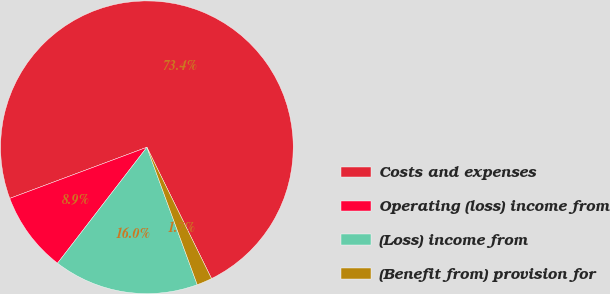Convert chart to OTSL. <chart><loc_0><loc_0><loc_500><loc_500><pie_chart><fcel>Costs and expenses<fcel>Operating (loss) income from<fcel>(Loss) income from<fcel>(Benefit from) provision for<nl><fcel>73.4%<fcel>8.87%<fcel>16.04%<fcel>1.69%<nl></chart> 